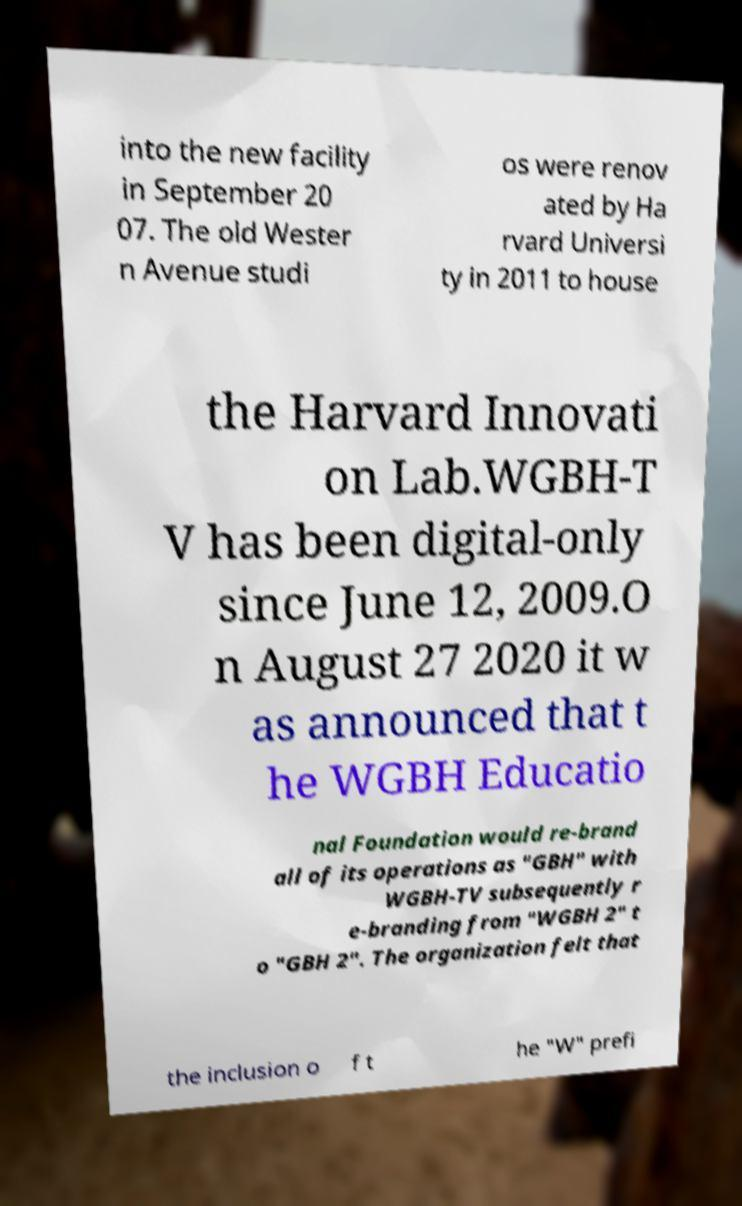For documentation purposes, I need the text within this image transcribed. Could you provide that? into the new facility in September 20 07. The old Wester n Avenue studi os were renov ated by Ha rvard Universi ty in 2011 to house the Harvard Innovati on Lab.WGBH-T V has been digital-only since June 12, 2009.O n August 27 2020 it w as announced that t he WGBH Educatio nal Foundation would re-brand all of its operations as "GBH" with WGBH-TV subsequently r e-branding from "WGBH 2" t o "GBH 2". The organization felt that the inclusion o f t he "W" prefi 